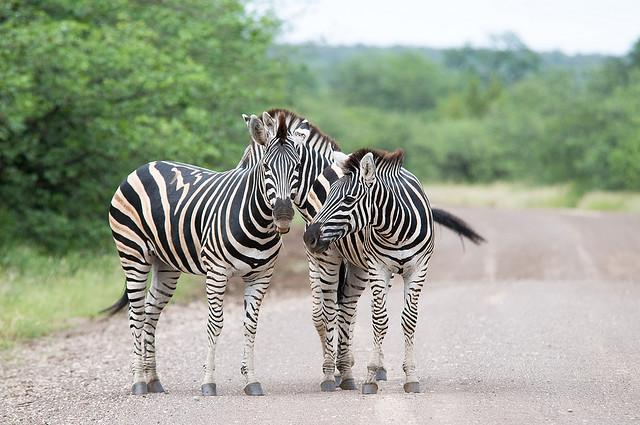What part of this photo would these animals never encounter in their natural habitat?

Choices:
A) trees
B) each other
C) grass
D) pavement pavement 